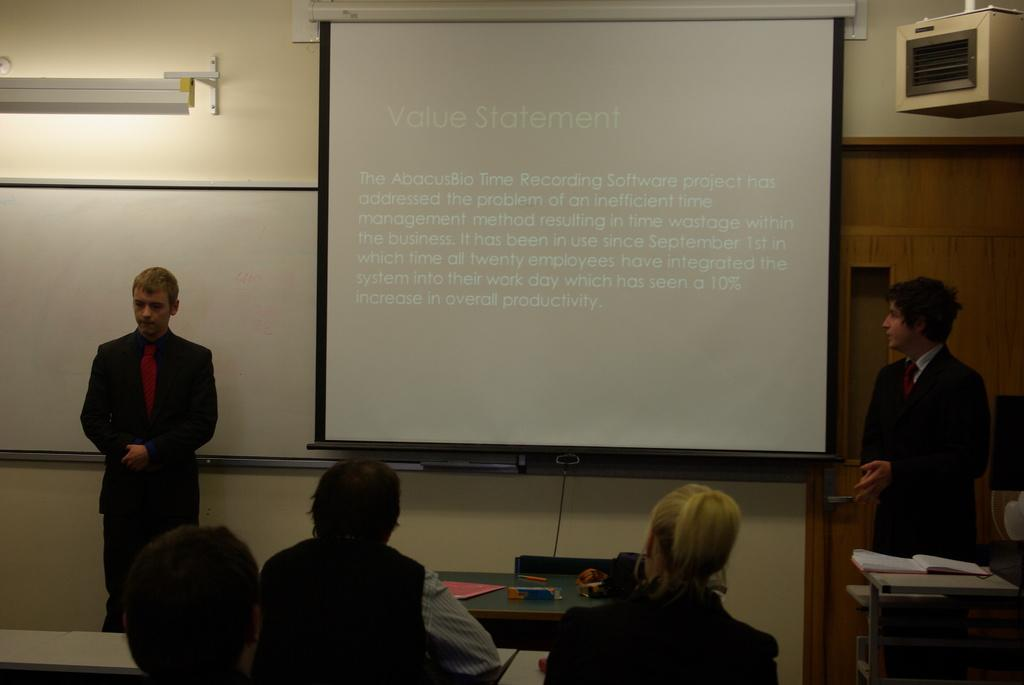How many people are in the image? There are multiple persons in the image. What are the people in the image doing? Some of the persons are sitting, while others are standing. What is the main object in the middle of the image? There is a projector screen in the middle of the image. What type of vegetable is being used as a chair by one of the persons in the image? There are no vegetables present in the image, and no one is using a vegetable as a chair. 